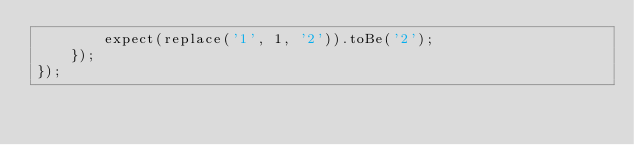<code> <loc_0><loc_0><loc_500><loc_500><_JavaScript_>        expect(replace('1', 1, '2')).toBe('2');
    });
});
</code> 